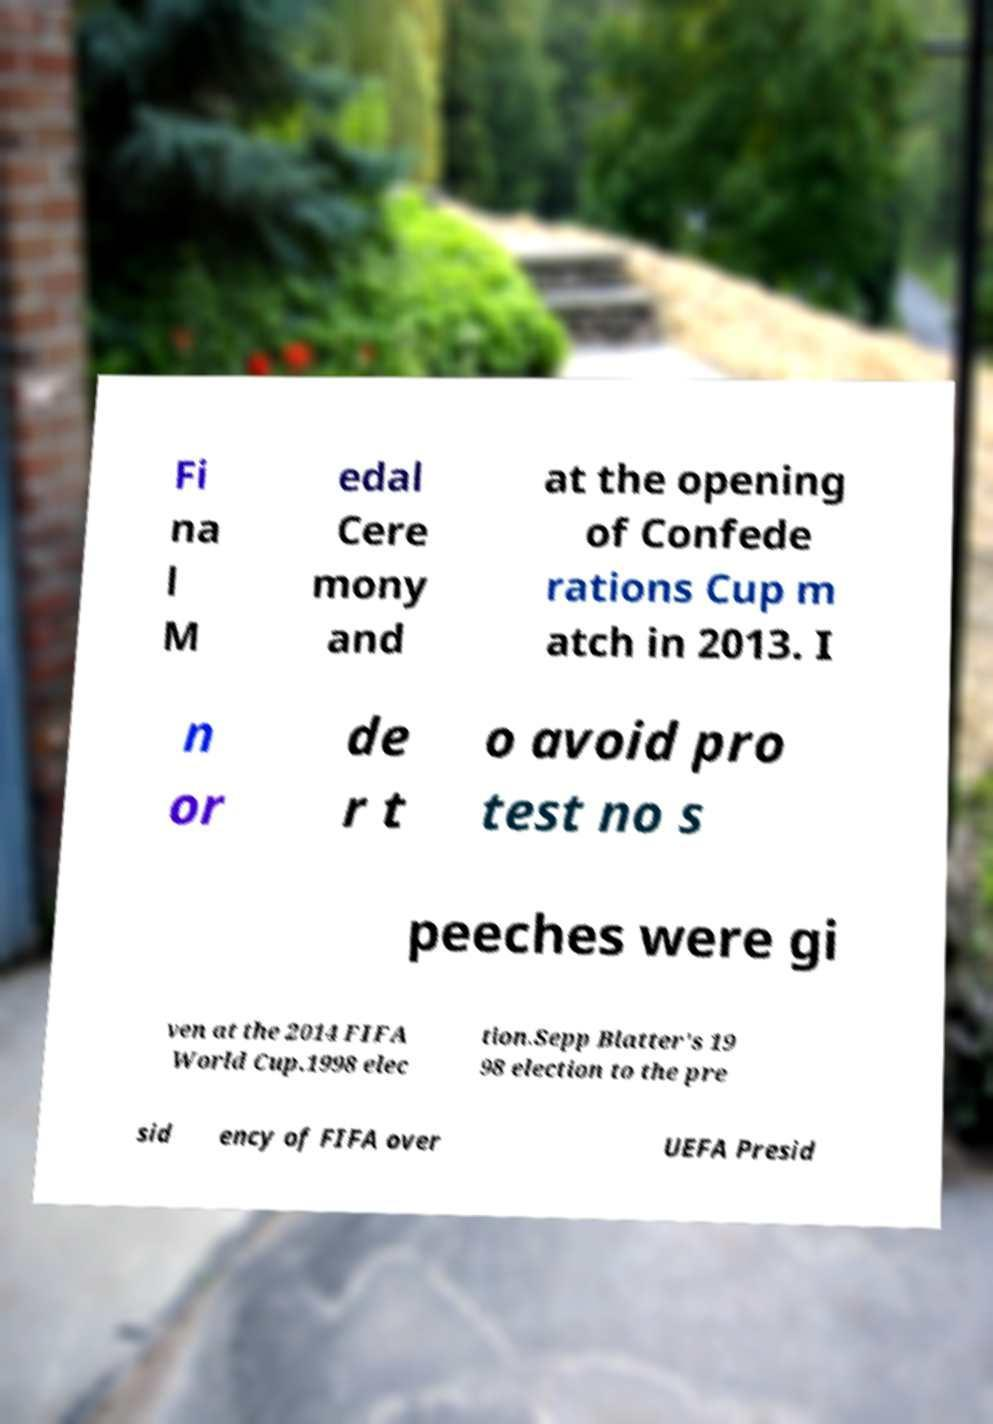Could you extract and type out the text from this image? Fi na l M edal Cere mony and at the opening of Confede rations Cup m atch in 2013. I n or de r t o avoid pro test no s peeches were gi ven at the 2014 FIFA World Cup.1998 elec tion.Sepp Blatter's 19 98 election to the pre sid ency of FIFA over UEFA Presid 